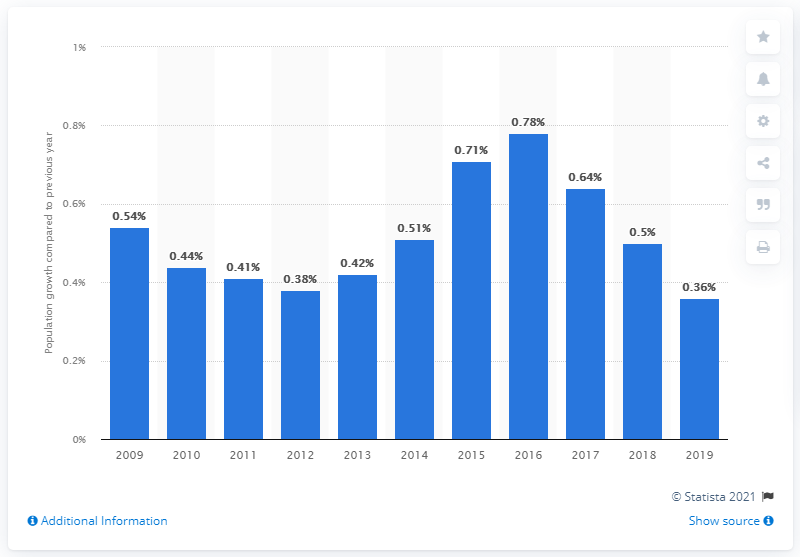Indicate a few pertinent items in this graphic. Denmark's population increased by 0.36% in 2019. 